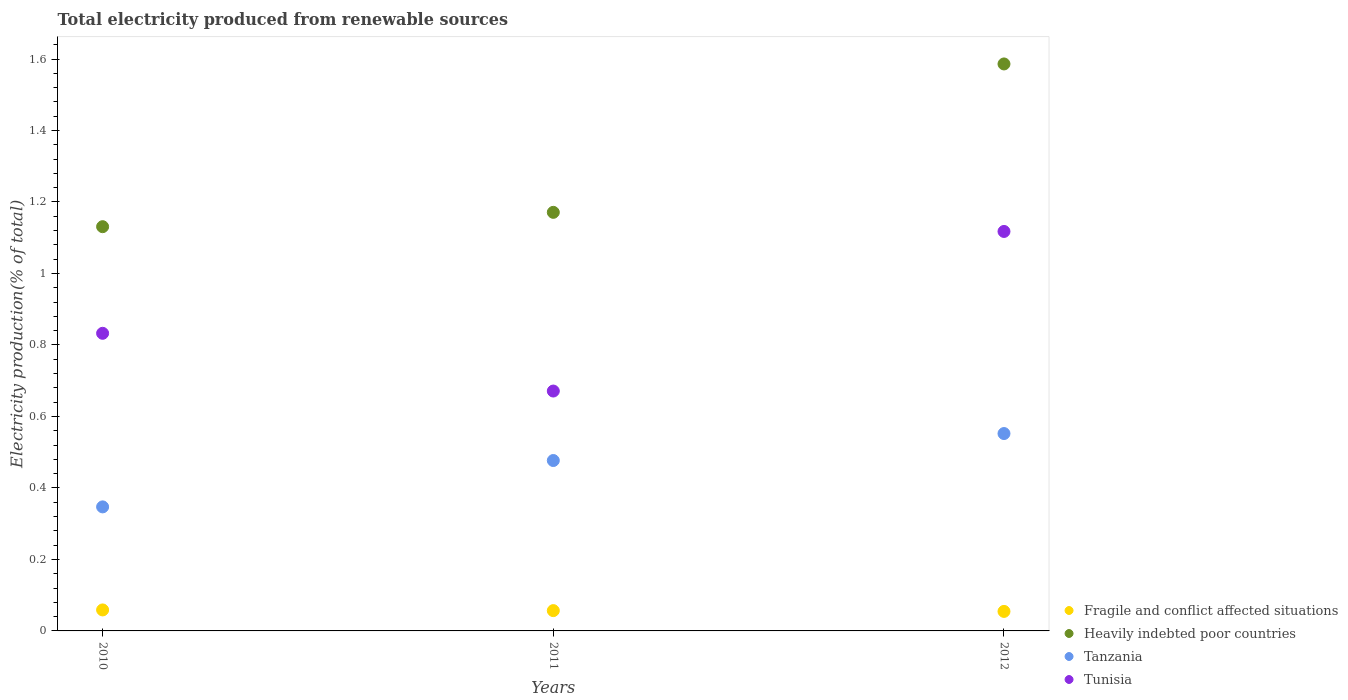Is the number of dotlines equal to the number of legend labels?
Give a very brief answer. Yes. What is the total electricity produced in Tunisia in 2010?
Give a very brief answer. 0.83. Across all years, what is the maximum total electricity produced in Tanzania?
Your answer should be compact. 0.55. Across all years, what is the minimum total electricity produced in Tanzania?
Give a very brief answer. 0.35. In which year was the total electricity produced in Heavily indebted poor countries maximum?
Offer a very short reply. 2012. What is the total total electricity produced in Tanzania in the graph?
Offer a terse response. 1.38. What is the difference between the total electricity produced in Tunisia in 2011 and that in 2012?
Offer a very short reply. -0.45. What is the difference between the total electricity produced in Heavily indebted poor countries in 2011 and the total electricity produced in Fragile and conflict affected situations in 2012?
Your answer should be very brief. 1.12. What is the average total electricity produced in Tunisia per year?
Your response must be concise. 0.87. In the year 2011, what is the difference between the total electricity produced in Fragile and conflict affected situations and total electricity produced in Tanzania?
Ensure brevity in your answer.  -0.42. In how many years, is the total electricity produced in Fragile and conflict affected situations greater than 1.4400000000000002 %?
Provide a succinct answer. 0. What is the ratio of the total electricity produced in Fragile and conflict affected situations in 2010 to that in 2012?
Your answer should be compact. 1.08. Is the total electricity produced in Heavily indebted poor countries in 2010 less than that in 2011?
Your answer should be very brief. Yes. Is the difference between the total electricity produced in Fragile and conflict affected situations in 2010 and 2011 greater than the difference between the total electricity produced in Tanzania in 2010 and 2011?
Offer a very short reply. Yes. What is the difference between the highest and the second highest total electricity produced in Tanzania?
Offer a very short reply. 0.08. What is the difference between the highest and the lowest total electricity produced in Tunisia?
Keep it short and to the point. 0.45. In how many years, is the total electricity produced in Tanzania greater than the average total electricity produced in Tanzania taken over all years?
Ensure brevity in your answer.  2. Is it the case that in every year, the sum of the total electricity produced in Fragile and conflict affected situations and total electricity produced in Heavily indebted poor countries  is greater than the sum of total electricity produced in Tunisia and total electricity produced in Tanzania?
Offer a terse response. Yes. Does the total electricity produced in Heavily indebted poor countries monotonically increase over the years?
Provide a short and direct response. Yes. Is the total electricity produced in Heavily indebted poor countries strictly less than the total electricity produced in Fragile and conflict affected situations over the years?
Give a very brief answer. No. How many dotlines are there?
Keep it short and to the point. 4. Are the values on the major ticks of Y-axis written in scientific E-notation?
Provide a succinct answer. No. Does the graph contain any zero values?
Your answer should be compact. No. What is the title of the graph?
Your response must be concise. Total electricity produced from renewable sources. Does "Ghana" appear as one of the legend labels in the graph?
Your answer should be compact. No. What is the label or title of the X-axis?
Ensure brevity in your answer.  Years. What is the Electricity production(% of total) of Fragile and conflict affected situations in 2010?
Offer a terse response. 0.06. What is the Electricity production(% of total) of Heavily indebted poor countries in 2010?
Your answer should be very brief. 1.13. What is the Electricity production(% of total) in Tanzania in 2010?
Offer a very short reply. 0.35. What is the Electricity production(% of total) in Tunisia in 2010?
Make the answer very short. 0.83. What is the Electricity production(% of total) in Fragile and conflict affected situations in 2011?
Your answer should be very brief. 0.06. What is the Electricity production(% of total) of Heavily indebted poor countries in 2011?
Your response must be concise. 1.17. What is the Electricity production(% of total) in Tanzania in 2011?
Your answer should be compact. 0.48. What is the Electricity production(% of total) of Tunisia in 2011?
Give a very brief answer. 0.67. What is the Electricity production(% of total) in Fragile and conflict affected situations in 2012?
Your answer should be very brief. 0.05. What is the Electricity production(% of total) of Heavily indebted poor countries in 2012?
Your answer should be very brief. 1.59. What is the Electricity production(% of total) in Tanzania in 2012?
Keep it short and to the point. 0.55. What is the Electricity production(% of total) in Tunisia in 2012?
Provide a succinct answer. 1.12. Across all years, what is the maximum Electricity production(% of total) of Fragile and conflict affected situations?
Give a very brief answer. 0.06. Across all years, what is the maximum Electricity production(% of total) of Heavily indebted poor countries?
Your response must be concise. 1.59. Across all years, what is the maximum Electricity production(% of total) in Tanzania?
Offer a very short reply. 0.55. Across all years, what is the maximum Electricity production(% of total) in Tunisia?
Your answer should be very brief. 1.12. Across all years, what is the minimum Electricity production(% of total) in Fragile and conflict affected situations?
Your answer should be very brief. 0.05. Across all years, what is the minimum Electricity production(% of total) in Heavily indebted poor countries?
Offer a terse response. 1.13. Across all years, what is the minimum Electricity production(% of total) of Tanzania?
Your answer should be compact. 0.35. Across all years, what is the minimum Electricity production(% of total) of Tunisia?
Your response must be concise. 0.67. What is the total Electricity production(% of total) of Fragile and conflict affected situations in the graph?
Your response must be concise. 0.17. What is the total Electricity production(% of total) of Heavily indebted poor countries in the graph?
Offer a very short reply. 3.89. What is the total Electricity production(% of total) in Tanzania in the graph?
Ensure brevity in your answer.  1.38. What is the total Electricity production(% of total) in Tunisia in the graph?
Your answer should be very brief. 2.62. What is the difference between the Electricity production(% of total) in Fragile and conflict affected situations in 2010 and that in 2011?
Give a very brief answer. 0. What is the difference between the Electricity production(% of total) of Heavily indebted poor countries in 2010 and that in 2011?
Make the answer very short. -0.04. What is the difference between the Electricity production(% of total) in Tanzania in 2010 and that in 2011?
Give a very brief answer. -0.13. What is the difference between the Electricity production(% of total) of Tunisia in 2010 and that in 2011?
Provide a short and direct response. 0.16. What is the difference between the Electricity production(% of total) of Fragile and conflict affected situations in 2010 and that in 2012?
Your answer should be compact. 0. What is the difference between the Electricity production(% of total) in Heavily indebted poor countries in 2010 and that in 2012?
Make the answer very short. -0.46. What is the difference between the Electricity production(% of total) of Tanzania in 2010 and that in 2012?
Ensure brevity in your answer.  -0.21. What is the difference between the Electricity production(% of total) in Tunisia in 2010 and that in 2012?
Provide a succinct answer. -0.28. What is the difference between the Electricity production(% of total) of Fragile and conflict affected situations in 2011 and that in 2012?
Give a very brief answer. 0. What is the difference between the Electricity production(% of total) of Heavily indebted poor countries in 2011 and that in 2012?
Ensure brevity in your answer.  -0.42. What is the difference between the Electricity production(% of total) of Tanzania in 2011 and that in 2012?
Provide a short and direct response. -0.08. What is the difference between the Electricity production(% of total) in Tunisia in 2011 and that in 2012?
Your response must be concise. -0.45. What is the difference between the Electricity production(% of total) in Fragile and conflict affected situations in 2010 and the Electricity production(% of total) in Heavily indebted poor countries in 2011?
Your answer should be compact. -1.11. What is the difference between the Electricity production(% of total) of Fragile and conflict affected situations in 2010 and the Electricity production(% of total) of Tanzania in 2011?
Your answer should be very brief. -0.42. What is the difference between the Electricity production(% of total) of Fragile and conflict affected situations in 2010 and the Electricity production(% of total) of Tunisia in 2011?
Your answer should be compact. -0.61. What is the difference between the Electricity production(% of total) in Heavily indebted poor countries in 2010 and the Electricity production(% of total) in Tanzania in 2011?
Provide a short and direct response. 0.65. What is the difference between the Electricity production(% of total) in Heavily indebted poor countries in 2010 and the Electricity production(% of total) in Tunisia in 2011?
Make the answer very short. 0.46. What is the difference between the Electricity production(% of total) in Tanzania in 2010 and the Electricity production(% of total) in Tunisia in 2011?
Your answer should be very brief. -0.32. What is the difference between the Electricity production(% of total) in Fragile and conflict affected situations in 2010 and the Electricity production(% of total) in Heavily indebted poor countries in 2012?
Your response must be concise. -1.53. What is the difference between the Electricity production(% of total) in Fragile and conflict affected situations in 2010 and the Electricity production(% of total) in Tanzania in 2012?
Keep it short and to the point. -0.49. What is the difference between the Electricity production(% of total) in Fragile and conflict affected situations in 2010 and the Electricity production(% of total) in Tunisia in 2012?
Your answer should be compact. -1.06. What is the difference between the Electricity production(% of total) in Heavily indebted poor countries in 2010 and the Electricity production(% of total) in Tanzania in 2012?
Offer a terse response. 0.58. What is the difference between the Electricity production(% of total) in Heavily indebted poor countries in 2010 and the Electricity production(% of total) in Tunisia in 2012?
Offer a very short reply. 0.01. What is the difference between the Electricity production(% of total) in Tanzania in 2010 and the Electricity production(% of total) in Tunisia in 2012?
Your answer should be very brief. -0.77. What is the difference between the Electricity production(% of total) of Fragile and conflict affected situations in 2011 and the Electricity production(% of total) of Heavily indebted poor countries in 2012?
Ensure brevity in your answer.  -1.53. What is the difference between the Electricity production(% of total) in Fragile and conflict affected situations in 2011 and the Electricity production(% of total) in Tanzania in 2012?
Offer a terse response. -0.5. What is the difference between the Electricity production(% of total) of Fragile and conflict affected situations in 2011 and the Electricity production(% of total) of Tunisia in 2012?
Make the answer very short. -1.06. What is the difference between the Electricity production(% of total) of Heavily indebted poor countries in 2011 and the Electricity production(% of total) of Tanzania in 2012?
Your answer should be compact. 0.62. What is the difference between the Electricity production(% of total) of Heavily indebted poor countries in 2011 and the Electricity production(% of total) of Tunisia in 2012?
Ensure brevity in your answer.  0.05. What is the difference between the Electricity production(% of total) in Tanzania in 2011 and the Electricity production(% of total) in Tunisia in 2012?
Offer a terse response. -0.64. What is the average Electricity production(% of total) of Fragile and conflict affected situations per year?
Your response must be concise. 0.06. What is the average Electricity production(% of total) of Heavily indebted poor countries per year?
Your answer should be compact. 1.3. What is the average Electricity production(% of total) of Tanzania per year?
Your answer should be compact. 0.46. What is the average Electricity production(% of total) in Tunisia per year?
Make the answer very short. 0.87. In the year 2010, what is the difference between the Electricity production(% of total) in Fragile and conflict affected situations and Electricity production(% of total) in Heavily indebted poor countries?
Provide a short and direct response. -1.07. In the year 2010, what is the difference between the Electricity production(% of total) in Fragile and conflict affected situations and Electricity production(% of total) in Tanzania?
Your response must be concise. -0.29. In the year 2010, what is the difference between the Electricity production(% of total) of Fragile and conflict affected situations and Electricity production(% of total) of Tunisia?
Keep it short and to the point. -0.77. In the year 2010, what is the difference between the Electricity production(% of total) of Heavily indebted poor countries and Electricity production(% of total) of Tanzania?
Keep it short and to the point. 0.78. In the year 2010, what is the difference between the Electricity production(% of total) in Heavily indebted poor countries and Electricity production(% of total) in Tunisia?
Give a very brief answer. 0.3. In the year 2010, what is the difference between the Electricity production(% of total) of Tanzania and Electricity production(% of total) of Tunisia?
Keep it short and to the point. -0.49. In the year 2011, what is the difference between the Electricity production(% of total) in Fragile and conflict affected situations and Electricity production(% of total) in Heavily indebted poor countries?
Offer a very short reply. -1.11. In the year 2011, what is the difference between the Electricity production(% of total) of Fragile and conflict affected situations and Electricity production(% of total) of Tanzania?
Make the answer very short. -0.42. In the year 2011, what is the difference between the Electricity production(% of total) in Fragile and conflict affected situations and Electricity production(% of total) in Tunisia?
Your response must be concise. -0.61. In the year 2011, what is the difference between the Electricity production(% of total) of Heavily indebted poor countries and Electricity production(% of total) of Tanzania?
Keep it short and to the point. 0.69. In the year 2011, what is the difference between the Electricity production(% of total) in Tanzania and Electricity production(% of total) in Tunisia?
Give a very brief answer. -0.19. In the year 2012, what is the difference between the Electricity production(% of total) in Fragile and conflict affected situations and Electricity production(% of total) in Heavily indebted poor countries?
Your answer should be compact. -1.53. In the year 2012, what is the difference between the Electricity production(% of total) of Fragile and conflict affected situations and Electricity production(% of total) of Tanzania?
Keep it short and to the point. -0.5. In the year 2012, what is the difference between the Electricity production(% of total) of Fragile and conflict affected situations and Electricity production(% of total) of Tunisia?
Offer a terse response. -1.06. In the year 2012, what is the difference between the Electricity production(% of total) of Heavily indebted poor countries and Electricity production(% of total) of Tanzania?
Make the answer very short. 1.03. In the year 2012, what is the difference between the Electricity production(% of total) of Heavily indebted poor countries and Electricity production(% of total) of Tunisia?
Provide a short and direct response. 0.47. In the year 2012, what is the difference between the Electricity production(% of total) of Tanzania and Electricity production(% of total) of Tunisia?
Provide a succinct answer. -0.57. What is the ratio of the Electricity production(% of total) of Fragile and conflict affected situations in 2010 to that in 2011?
Your answer should be very brief. 1.03. What is the ratio of the Electricity production(% of total) of Heavily indebted poor countries in 2010 to that in 2011?
Your answer should be very brief. 0.97. What is the ratio of the Electricity production(% of total) in Tanzania in 2010 to that in 2011?
Your answer should be very brief. 0.73. What is the ratio of the Electricity production(% of total) of Tunisia in 2010 to that in 2011?
Offer a very short reply. 1.24. What is the ratio of the Electricity production(% of total) in Fragile and conflict affected situations in 2010 to that in 2012?
Provide a short and direct response. 1.08. What is the ratio of the Electricity production(% of total) of Heavily indebted poor countries in 2010 to that in 2012?
Your answer should be very brief. 0.71. What is the ratio of the Electricity production(% of total) in Tanzania in 2010 to that in 2012?
Offer a terse response. 0.63. What is the ratio of the Electricity production(% of total) in Tunisia in 2010 to that in 2012?
Offer a very short reply. 0.74. What is the ratio of the Electricity production(% of total) in Fragile and conflict affected situations in 2011 to that in 2012?
Your answer should be very brief. 1.04. What is the ratio of the Electricity production(% of total) of Heavily indebted poor countries in 2011 to that in 2012?
Offer a very short reply. 0.74. What is the ratio of the Electricity production(% of total) in Tanzania in 2011 to that in 2012?
Your answer should be compact. 0.86. What is the ratio of the Electricity production(% of total) of Tunisia in 2011 to that in 2012?
Ensure brevity in your answer.  0.6. What is the difference between the highest and the second highest Electricity production(% of total) of Fragile and conflict affected situations?
Keep it short and to the point. 0. What is the difference between the highest and the second highest Electricity production(% of total) in Heavily indebted poor countries?
Make the answer very short. 0.42. What is the difference between the highest and the second highest Electricity production(% of total) of Tanzania?
Keep it short and to the point. 0.08. What is the difference between the highest and the second highest Electricity production(% of total) of Tunisia?
Your answer should be very brief. 0.28. What is the difference between the highest and the lowest Electricity production(% of total) in Fragile and conflict affected situations?
Your response must be concise. 0. What is the difference between the highest and the lowest Electricity production(% of total) of Heavily indebted poor countries?
Your answer should be very brief. 0.46. What is the difference between the highest and the lowest Electricity production(% of total) of Tanzania?
Offer a very short reply. 0.21. What is the difference between the highest and the lowest Electricity production(% of total) in Tunisia?
Provide a short and direct response. 0.45. 